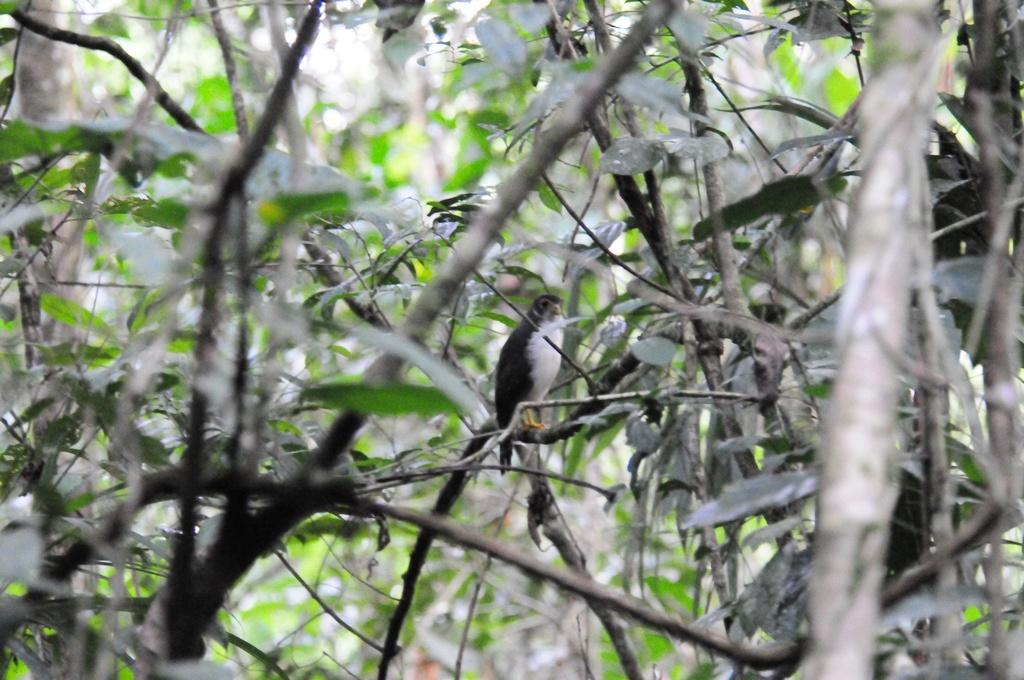What type of vegetation can be seen in the image? There are trees in the image. How would you describe the background of the image? The background of the image is blurred. Can you see any worms crawling on the trees in the image? There is no indication of worms or any other creatures on the trees in the image. What type of fuel is being used by the trees in the image? Trees do not use fuel; they produce their own energy through photosynthesis. 